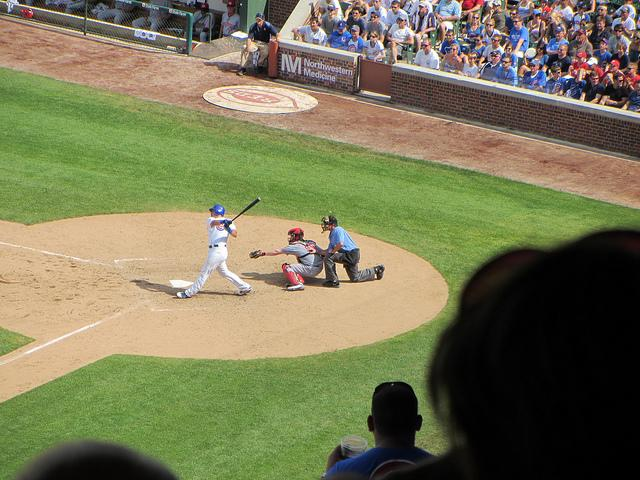What does Northwestern Medicine provide in this game?

Choices:
A) medical service
B) medical advice
C) drugs
D) sponsor sponsor 